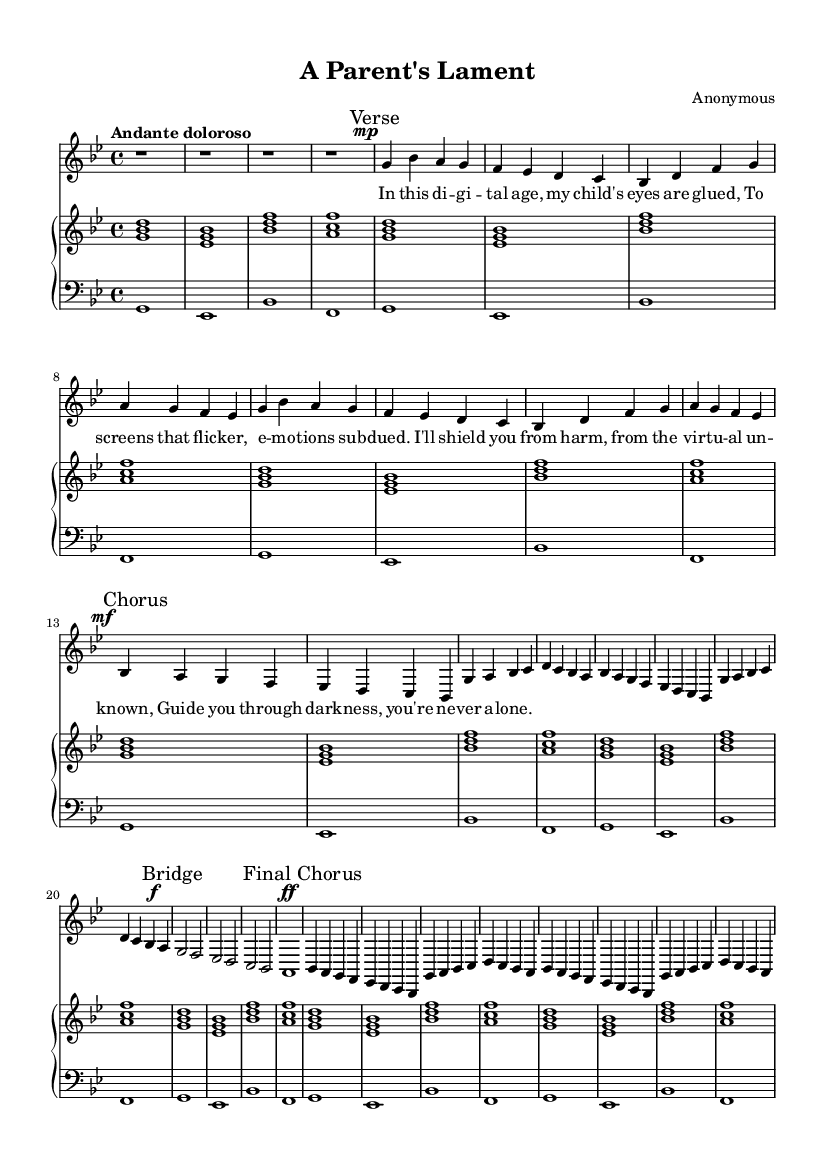What is the key signature of this music? The key signature indicated in the score shows two flats, which corresponds to the key of G minor.
Answer: G minor What is the time signature of this piece? The time signature is displayed as four beats per measure, represented by the notation 4/4.
Answer: 4/4 What is the tempo marking for this piece? The tempo marking states "Andante doloroso," indicating a slow and expressive pace.
Answer: Andante doloroso How many verses are present in this opera? The score contains one verse section, indicated by the marking "Verse."
Answer: One What dynamic marking is used during the chorus? The chorus section is marked with a dynamic of "mf," which stands for mezzo-forte, indicating a medium loudness.
Answer: mf What is the primary theme expressed in the lyrics? The primary theme revolves around a parent's desire to protect their child from online threats, emphasizing an emotional tone throughout.
Answer: Protection What is the structure of the opera indicated in the score? The score has a clear structure that includes an introduction, verse, chorus, bridge, and a final chorus, highlighting its operatic form.
Answer: Introduction, Verse, Chorus, Bridge, Final Chorus 